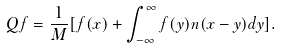<formula> <loc_0><loc_0><loc_500><loc_500>Q f = \frac { 1 } { M } [ f ( x ) + \int _ { - \infty } ^ { \infty } f ( y ) n ( x - y ) d y ] .</formula> 